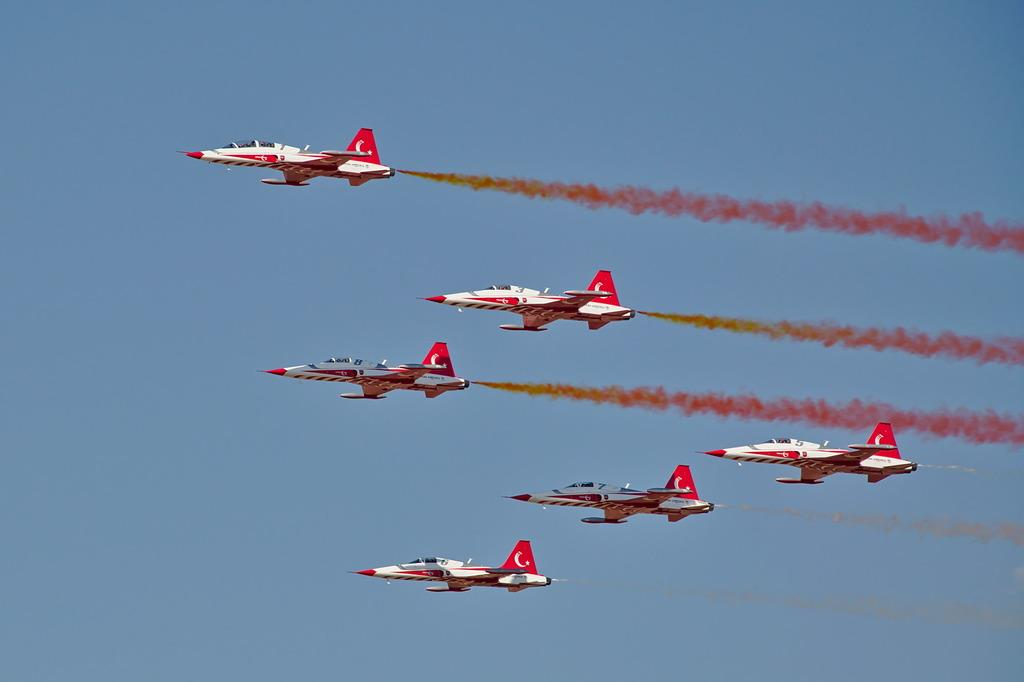What is the main subject of the image? The main subject of the image is aircraft. Where are the aircraft located in the image? The aircraft are in the air. What can be seen coming from the aircraft in the image? There is smoke visible in the image. What color is the background of the image? The background of the image is blue. What type of holiday is being celebrated in the image? There is no indication of a holiday being celebrated in the image; it features aircraft in the air with smoke. What is the texture of the page on which the image is printed? The provided facts do not mention the image being printed on a page, so we cannot determine its texture. 